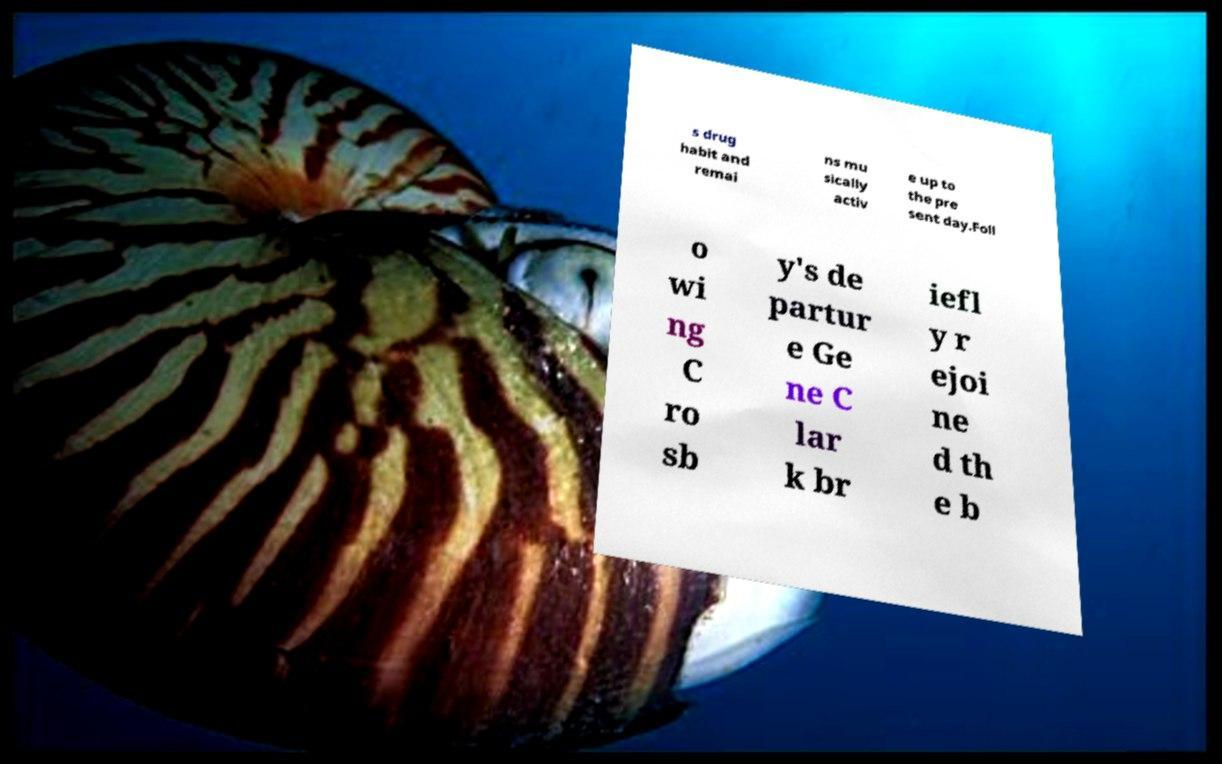I need the written content from this picture converted into text. Can you do that? s drug habit and remai ns mu sically activ e up to the pre sent day.Foll o wi ng C ro sb y's de partur e Ge ne C lar k br iefl y r ejoi ne d th e b 